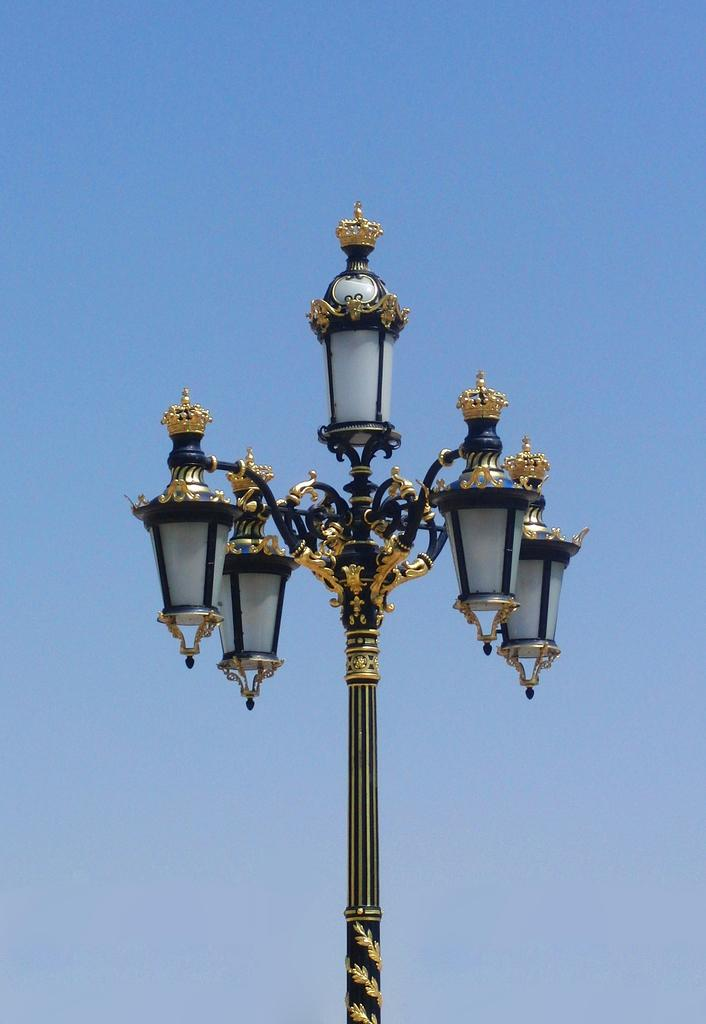What is the color of the pole in the image? The pole in the image is black and gold. Are there any additional features on the pole? Yes, the pole has lights on it. What can be seen in the background of the image? There is a sky visible in the background of the image. What is the grandfather cooking in the image? There is no grandfather or cooking activity present in the image. 